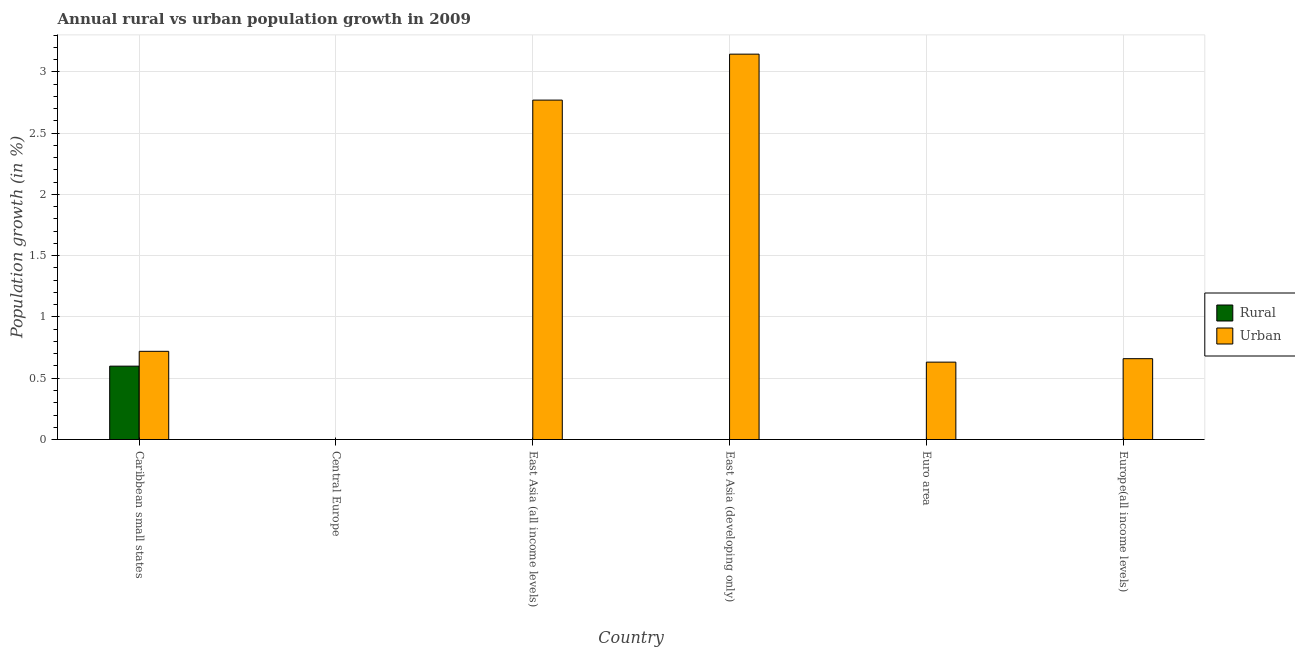Are the number of bars per tick equal to the number of legend labels?
Offer a very short reply. No. How many bars are there on the 1st tick from the left?
Your answer should be very brief. 2. What is the label of the 2nd group of bars from the left?
Give a very brief answer. Central Europe. Across all countries, what is the maximum urban population growth?
Provide a short and direct response. 3.14. In which country was the urban population growth maximum?
Offer a terse response. East Asia (developing only). What is the total urban population growth in the graph?
Your answer should be compact. 7.93. What is the difference between the urban population growth in East Asia (developing only) and that in Europe(all income levels)?
Offer a very short reply. 2.49. What is the difference between the urban population growth in East Asia (developing only) and the rural population growth in East Asia (all income levels)?
Ensure brevity in your answer.  3.14. What is the average urban population growth per country?
Your answer should be very brief. 1.32. What is the difference between the urban population growth and rural population growth in Caribbean small states?
Your answer should be very brief. 0.12. In how many countries, is the urban population growth greater than 2.9 %?
Offer a very short reply. 1. What is the ratio of the urban population growth in East Asia (developing only) to that in Euro area?
Make the answer very short. 4.98. What is the difference between the highest and the second highest urban population growth?
Ensure brevity in your answer.  0.38. What is the difference between the highest and the lowest urban population growth?
Your response must be concise. 3.14. Is the sum of the urban population growth in East Asia (all income levels) and East Asia (developing only) greater than the maximum rural population growth across all countries?
Provide a short and direct response. Yes. How many countries are there in the graph?
Offer a very short reply. 6. What is the difference between two consecutive major ticks on the Y-axis?
Make the answer very short. 0.5. Does the graph contain any zero values?
Provide a short and direct response. Yes. What is the title of the graph?
Ensure brevity in your answer.  Annual rural vs urban population growth in 2009. Does "Central government" appear as one of the legend labels in the graph?
Offer a terse response. No. What is the label or title of the Y-axis?
Ensure brevity in your answer.  Population growth (in %). What is the Population growth (in %) in Rural in Caribbean small states?
Your answer should be very brief. 0.6. What is the Population growth (in %) in Urban  in Caribbean small states?
Your answer should be very brief. 0.72. What is the Population growth (in %) in Rural in East Asia (all income levels)?
Ensure brevity in your answer.  0. What is the Population growth (in %) in Urban  in East Asia (all income levels)?
Your answer should be very brief. 2.77. What is the Population growth (in %) of Urban  in East Asia (developing only)?
Your answer should be very brief. 3.14. What is the Population growth (in %) of Rural in Euro area?
Provide a short and direct response. 0. What is the Population growth (in %) in Urban  in Euro area?
Offer a terse response. 0.63. What is the Population growth (in %) in Urban  in Europe(all income levels)?
Your response must be concise. 0.66. Across all countries, what is the maximum Population growth (in %) of Rural?
Your answer should be compact. 0.6. Across all countries, what is the maximum Population growth (in %) of Urban ?
Offer a very short reply. 3.14. What is the total Population growth (in %) of Rural in the graph?
Ensure brevity in your answer.  0.6. What is the total Population growth (in %) of Urban  in the graph?
Your answer should be compact. 7.93. What is the difference between the Population growth (in %) in Urban  in Caribbean small states and that in East Asia (all income levels)?
Offer a terse response. -2.05. What is the difference between the Population growth (in %) of Urban  in Caribbean small states and that in East Asia (developing only)?
Provide a short and direct response. -2.43. What is the difference between the Population growth (in %) of Urban  in Caribbean small states and that in Euro area?
Your answer should be very brief. 0.09. What is the difference between the Population growth (in %) of Urban  in East Asia (all income levels) and that in East Asia (developing only)?
Ensure brevity in your answer.  -0.38. What is the difference between the Population growth (in %) in Urban  in East Asia (all income levels) and that in Euro area?
Offer a terse response. 2.14. What is the difference between the Population growth (in %) of Urban  in East Asia (all income levels) and that in Europe(all income levels)?
Offer a terse response. 2.11. What is the difference between the Population growth (in %) of Urban  in East Asia (developing only) and that in Euro area?
Make the answer very short. 2.51. What is the difference between the Population growth (in %) in Urban  in East Asia (developing only) and that in Europe(all income levels)?
Offer a very short reply. 2.48. What is the difference between the Population growth (in %) of Urban  in Euro area and that in Europe(all income levels)?
Keep it short and to the point. -0.03. What is the difference between the Population growth (in %) of Rural in Caribbean small states and the Population growth (in %) of Urban  in East Asia (all income levels)?
Keep it short and to the point. -2.17. What is the difference between the Population growth (in %) of Rural in Caribbean small states and the Population growth (in %) of Urban  in East Asia (developing only)?
Your response must be concise. -2.55. What is the difference between the Population growth (in %) of Rural in Caribbean small states and the Population growth (in %) of Urban  in Euro area?
Make the answer very short. -0.03. What is the difference between the Population growth (in %) in Rural in Caribbean small states and the Population growth (in %) in Urban  in Europe(all income levels)?
Make the answer very short. -0.06. What is the average Population growth (in %) in Rural per country?
Your response must be concise. 0.1. What is the average Population growth (in %) in Urban  per country?
Keep it short and to the point. 1.32. What is the difference between the Population growth (in %) in Rural and Population growth (in %) in Urban  in Caribbean small states?
Keep it short and to the point. -0.12. What is the ratio of the Population growth (in %) in Urban  in Caribbean small states to that in East Asia (all income levels)?
Provide a short and direct response. 0.26. What is the ratio of the Population growth (in %) of Urban  in Caribbean small states to that in East Asia (developing only)?
Your answer should be compact. 0.23. What is the ratio of the Population growth (in %) of Urban  in Caribbean small states to that in Euro area?
Ensure brevity in your answer.  1.14. What is the ratio of the Population growth (in %) of Urban  in East Asia (all income levels) to that in East Asia (developing only)?
Make the answer very short. 0.88. What is the ratio of the Population growth (in %) of Urban  in East Asia (all income levels) to that in Euro area?
Offer a terse response. 4.39. What is the ratio of the Population growth (in %) in Urban  in East Asia (all income levels) to that in Europe(all income levels)?
Ensure brevity in your answer.  4.2. What is the ratio of the Population growth (in %) in Urban  in East Asia (developing only) to that in Euro area?
Your answer should be very brief. 4.98. What is the ratio of the Population growth (in %) in Urban  in East Asia (developing only) to that in Europe(all income levels)?
Provide a short and direct response. 4.77. What is the ratio of the Population growth (in %) in Urban  in Euro area to that in Europe(all income levels)?
Your answer should be very brief. 0.96. What is the difference between the highest and the second highest Population growth (in %) in Urban ?
Ensure brevity in your answer.  0.38. What is the difference between the highest and the lowest Population growth (in %) of Rural?
Provide a succinct answer. 0.6. What is the difference between the highest and the lowest Population growth (in %) of Urban ?
Offer a terse response. 3.14. 